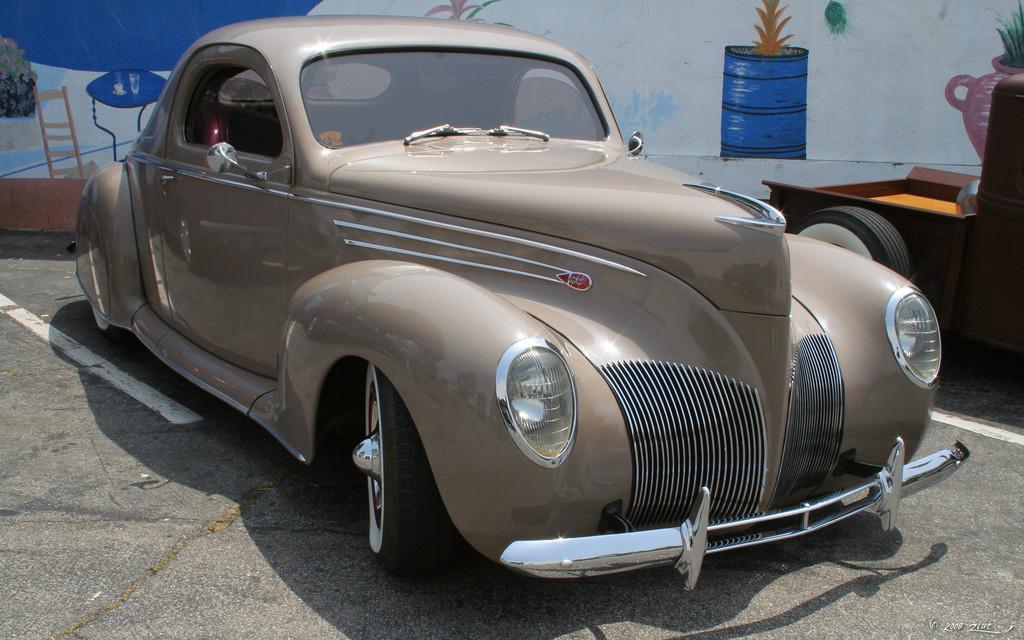In one or two sentences, can you explain what this image depicts? In this picture we can see a car on the road and in the background we can see a wall with a painting on it. 